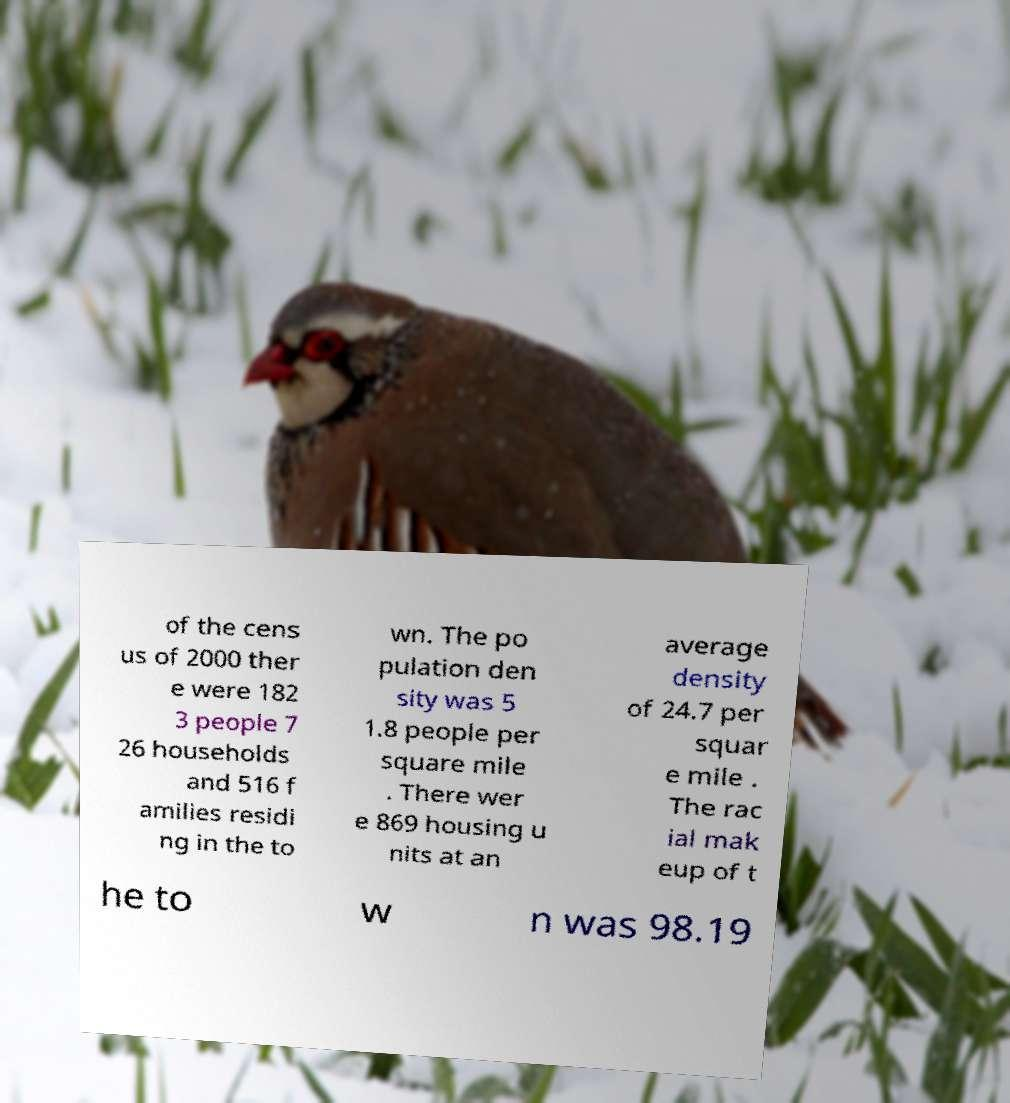Could you assist in decoding the text presented in this image and type it out clearly? of the cens us of 2000 ther e were 182 3 people 7 26 households and 516 f amilies residi ng in the to wn. The po pulation den sity was 5 1.8 people per square mile . There wer e 869 housing u nits at an average density of 24.7 per squar e mile . The rac ial mak eup of t he to w n was 98.19 